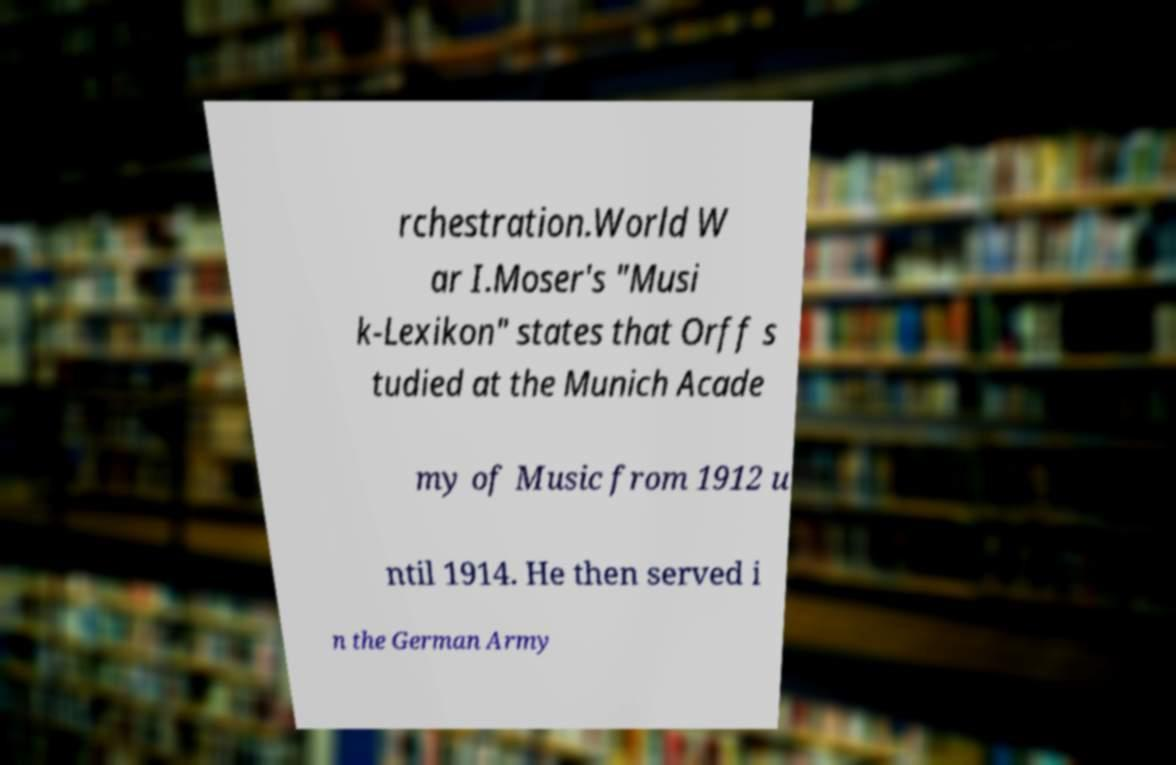Can you accurately transcribe the text from the provided image for me? rchestration.World W ar I.Moser's "Musi k-Lexikon" states that Orff s tudied at the Munich Acade my of Music from 1912 u ntil 1914. He then served i n the German Army 